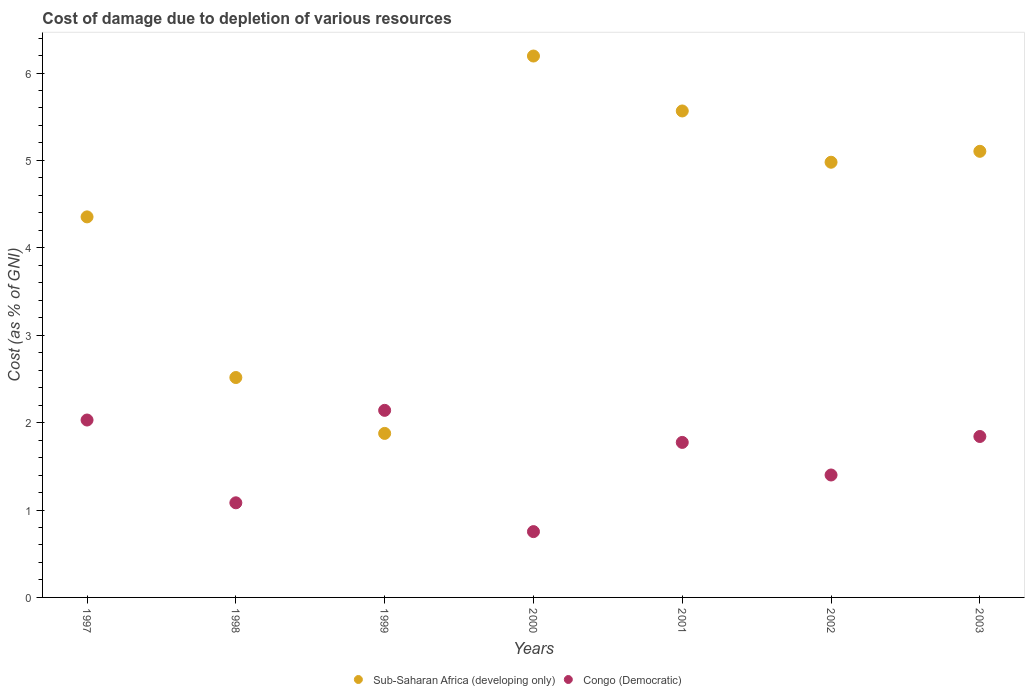How many different coloured dotlines are there?
Offer a very short reply. 2. Is the number of dotlines equal to the number of legend labels?
Ensure brevity in your answer.  Yes. What is the cost of damage caused due to the depletion of various resources in Sub-Saharan Africa (developing only) in 1998?
Make the answer very short. 2.52. Across all years, what is the maximum cost of damage caused due to the depletion of various resources in Congo (Democratic)?
Your answer should be compact. 2.14. Across all years, what is the minimum cost of damage caused due to the depletion of various resources in Congo (Democratic)?
Your answer should be compact. 0.75. In which year was the cost of damage caused due to the depletion of various resources in Sub-Saharan Africa (developing only) minimum?
Provide a succinct answer. 1999. What is the total cost of damage caused due to the depletion of various resources in Sub-Saharan Africa (developing only) in the graph?
Ensure brevity in your answer.  30.59. What is the difference between the cost of damage caused due to the depletion of various resources in Sub-Saharan Africa (developing only) in 1998 and that in 1999?
Your answer should be compact. 0.64. What is the difference between the cost of damage caused due to the depletion of various resources in Sub-Saharan Africa (developing only) in 2002 and the cost of damage caused due to the depletion of various resources in Congo (Democratic) in 2003?
Ensure brevity in your answer.  3.14. What is the average cost of damage caused due to the depletion of various resources in Congo (Democratic) per year?
Your response must be concise. 1.57. In the year 2001, what is the difference between the cost of damage caused due to the depletion of various resources in Sub-Saharan Africa (developing only) and cost of damage caused due to the depletion of various resources in Congo (Democratic)?
Offer a terse response. 3.79. What is the ratio of the cost of damage caused due to the depletion of various resources in Congo (Democratic) in 1999 to that in 2002?
Your response must be concise. 1.53. What is the difference between the highest and the second highest cost of damage caused due to the depletion of various resources in Sub-Saharan Africa (developing only)?
Ensure brevity in your answer.  0.63. What is the difference between the highest and the lowest cost of damage caused due to the depletion of various resources in Sub-Saharan Africa (developing only)?
Your answer should be compact. 4.32. Does the cost of damage caused due to the depletion of various resources in Congo (Democratic) monotonically increase over the years?
Keep it short and to the point. No. Is the cost of damage caused due to the depletion of various resources in Congo (Democratic) strictly greater than the cost of damage caused due to the depletion of various resources in Sub-Saharan Africa (developing only) over the years?
Your answer should be compact. No. How many dotlines are there?
Provide a short and direct response. 2. Are the values on the major ticks of Y-axis written in scientific E-notation?
Offer a very short reply. No. Does the graph contain any zero values?
Your answer should be compact. No. Does the graph contain grids?
Ensure brevity in your answer.  No. Where does the legend appear in the graph?
Offer a very short reply. Bottom center. How are the legend labels stacked?
Provide a succinct answer. Horizontal. What is the title of the graph?
Provide a short and direct response. Cost of damage due to depletion of various resources. Does "Antigua and Barbuda" appear as one of the legend labels in the graph?
Provide a short and direct response. No. What is the label or title of the X-axis?
Provide a short and direct response. Years. What is the label or title of the Y-axis?
Make the answer very short. Cost (as % of GNI). What is the Cost (as % of GNI) in Sub-Saharan Africa (developing only) in 1997?
Make the answer very short. 4.35. What is the Cost (as % of GNI) of Congo (Democratic) in 1997?
Make the answer very short. 2.03. What is the Cost (as % of GNI) in Sub-Saharan Africa (developing only) in 1998?
Ensure brevity in your answer.  2.52. What is the Cost (as % of GNI) of Congo (Democratic) in 1998?
Ensure brevity in your answer.  1.08. What is the Cost (as % of GNI) of Sub-Saharan Africa (developing only) in 1999?
Your answer should be compact. 1.88. What is the Cost (as % of GNI) of Congo (Democratic) in 1999?
Offer a terse response. 2.14. What is the Cost (as % of GNI) of Sub-Saharan Africa (developing only) in 2000?
Offer a terse response. 6.19. What is the Cost (as % of GNI) in Congo (Democratic) in 2000?
Offer a very short reply. 0.75. What is the Cost (as % of GNI) in Sub-Saharan Africa (developing only) in 2001?
Your answer should be very brief. 5.57. What is the Cost (as % of GNI) of Congo (Democratic) in 2001?
Make the answer very short. 1.77. What is the Cost (as % of GNI) in Sub-Saharan Africa (developing only) in 2002?
Give a very brief answer. 4.98. What is the Cost (as % of GNI) in Congo (Democratic) in 2002?
Make the answer very short. 1.4. What is the Cost (as % of GNI) of Sub-Saharan Africa (developing only) in 2003?
Make the answer very short. 5.1. What is the Cost (as % of GNI) of Congo (Democratic) in 2003?
Give a very brief answer. 1.84. Across all years, what is the maximum Cost (as % of GNI) of Sub-Saharan Africa (developing only)?
Your response must be concise. 6.19. Across all years, what is the maximum Cost (as % of GNI) in Congo (Democratic)?
Offer a terse response. 2.14. Across all years, what is the minimum Cost (as % of GNI) of Sub-Saharan Africa (developing only)?
Make the answer very short. 1.88. Across all years, what is the minimum Cost (as % of GNI) in Congo (Democratic)?
Your response must be concise. 0.75. What is the total Cost (as % of GNI) of Sub-Saharan Africa (developing only) in the graph?
Give a very brief answer. 30.59. What is the total Cost (as % of GNI) in Congo (Democratic) in the graph?
Provide a succinct answer. 11.02. What is the difference between the Cost (as % of GNI) in Sub-Saharan Africa (developing only) in 1997 and that in 1998?
Provide a short and direct response. 1.84. What is the difference between the Cost (as % of GNI) of Congo (Democratic) in 1997 and that in 1998?
Your answer should be compact. 0.95. What is the difference between the Cost (as % of GNI) in Sub-Saharan Africa (developing only) in 1997 and that in 1999?
Provide a short and direct response. 2.48. What is the difference between the Cost (as % of GNI) in Congo (Democratic) in 1997 and that in 1999?
Offer a very short reply. -0.11. What is the difference between the Cost (as % of GNI) in Sub-Saharan Africa (developing only) in 1997 and that in 2000?
Offer a very short reply. -1.84. What is the difference between the Cost (as % of GNI) in Congo (Democratic) in 1997 and that in 2000?
Your response must be concise. 1.28. What is the difference between the Cost (as % of GNI) in Sub-Saharan Africa (developing only) in 1997 and that in 2001?
Give a very brief answer. -1.21. What is the difference between the Cost (as % of GNI) in Congo (Democratic) in 1997 and that in 2001?
Offer a very short reply. 0.26. What is the difference between the Cost (as % of GNI) in Sub-Saharan Africa (developing only) in 1997 and that in 2002?
Your response must be concise. -0.63. What is the difference between the Cost (as % of GNI) of Congo (Democratic) in 1997 and that in 2002?
Your response must be concise. 0.63. What is the difference between the Cost (as % of GNI) in Sub-Saharan Africa (developing only) in 1997 and that in 2003?
Provide a succinct answer. -0.75. What is the difference between the Cost (as % of GNI) of Congo (Democratic) in 1997 and that in 2003?
Your answer should be very brief. 0.19. What is the difference between the Cost (as % of GNI) of Sub-Saharan Africa (developing only) in 1998 and that in 1999?
Make the answer very short. 0.64. What is the difference between the Cost (as % of GNI) of Congo (Democratic) in 1998 and that in 1999?
Your response must be concise. -1.06. What is the difference between the Cost (as % of GNI) in Sub-Saharan Africa (developing only) in 1998 and that in 2000?
Your answer should be very brief. -3.68. What is the difference between the Cost (as % of GNI) of Congo (Democratic) in 1998 and that in 2000?
Your response must be concise. 0.33. What is the difference between the Cost (as % of GNI) of Sub-Saharan Africa (developing only) in 1998 and that in 2001?
Keep it short and to the point. -3.05. What is the difference between the Cost (as % of GNI) in Congo (Democratic) in 1998 and that in 2001?
Make the answer very short. -0.69. What is the difference between the Cost (as % of GNI) in Sub-Saharan Africa (developing only) in 1998 and that in 2002?
Offer a terse response. -2.46. What is the difference between the Cost (as % of GNI) of Congo (Democratic) in 1998 and that in 2002?
Your answer should be compact. -0.32. What is the difference between the Cost (as % of GNI) of Sub-Saharan Africa (developing only) in 1998 and that in 2003?
Offer a very short reply. -2.59. What is the difference between the Cost (as % of GNI) in Congo (Democratic) in 1998 and that in 2003?
Offer a very short reply. -0.76. What is the difference between the Cost (as % of GNI) of Sub-Saharan Africa (developing only) in 1999 and that in 2000?
Your response must be concise. -4.32. What is the difference between the Cost (as % of GNI) in Congo (Democratic) in 1999 and that in 2000?
Provide a short and direct response. 1.39. What is the difference between the Cost (as % of GNI) of Sub-Saharan Africa (developing only) in 1999 and that in 2001?
Your response must be concise. -3.69. What is the difference between the Cost (as % of GNI) in Congo (Democratic) in 1999 and that in 2001?
Give a very brief answer. 0.37. What is the difference between the Cost (as % of GNI) in Sub-Saharan Africa (developing only) in 1999 and that in 2002?
Your answer should be very brief. -3.1. What is the difference between the Cost (as % of GNI) of Congo (Democratic) in 1999 and that in 2002?
Your answer should be very brief. 0.74. What is the difference between the Cost (as % of GNI) of Sub-Saharan Africa (developing only) in 1999 and that in 2003?
Offer a terse response. -3.23. What is the difference between the Cost (as % of GNI) in Congo (Democratic) in 1999 and that in 2003?
Your response must be concise. 0.3. What is the difference between the Cost (as % of GNI) in Sub-Saharan Africa (developing only) in 2000 and that in 2001?
Your answer should be compact. 0.63. What is the difference between the Cost (as % of GNI) of Congo (Democratic) in 2000 and that in 2001?
Provide a succinct answer. -1.02. What is the difference between the Cost (as % of GNI) of Sub-Saharan Africa (developing only) in 2000 and that in 2002?
Provide a short and direct response. 1.22. What is the difference between the Cost (as % of GNI) in Congo (Democratic) in 2000 and that in 2002?
Offer a very short reply. -0.65. What is the difference between the Cost (as % of GNI) of Sub-Saharan Africa (developing only) in 2000 and that in 2003?
Ensure brevity in your answer.  1.09. What is the difference between the Cost (as % of GNI) of Congo (Democratic) in 2000 and that in 2003?
Your answer should be compact. -1.09. What is the difference between the Cost (as % of GNI) in Sub-Saharan Africa (developing only) in 2001 and that in 2002?
Your answer should be compact. 0.59. What is the difference between the Cost (as % of GNI) in Congo (Democratic) in 2001 and that in 2002?
Your answer should be compact. 0.37. What is the difference between the Cost (as % of GNI) in Sub-Saharan Africa (developing only) in 2001 and that in 2003?
Give a very brief answer. 0.46. What is the difference between the Cost (as % of GNI) in Congo (Democratic) in 2001 and that in 2003?
Provide a succinct answer. -0.07. What is the difference between the Cost (as % of GNI) of Sub-Saharan Africa (developing only) in 2002 and that in 2003?
Offer a very short reply. -0.12. What is the difference between the Cost (as % of GNI) of Congo (Democratic) in 2002 and that in 2003?
Your response must be concise. -0.44. What is the difference between the Cost (as % of GNI) in Sub-Saharan Africa (developing only) in 1997 and the Cost (as % of GNI) in Congo (Democratic) in 1998?
Keep it short and to the point. 3.27. What is the difference between the Cost (as % of GNI) of Sub-Saharan Africa (developing only) in 1997 and the Cost (as % of GNI) of Congo (Democratic) in 1999?
Provide a succinct answer. 2.21. What is the difference between the Cost (as % of GNI) of Sub-Saharan Africa (developing only) in 1997 and the Cost (as % of GNI) of Congo (Democratic) in 2000?
Offer a very short reply. 3.6. What is the difference between the Cost (as % of GNI) of Sub-Saharan Africa (developing only) in 1997 and the Cost (as % of GNI) of Congo (Democratic) in 2001?
Provide a succinct answer. 2.58. What is the difference between the Cost (as % of GNI) of Sub-Saharan Africa (developing only) in 1997 and the Cost (as % of GNI) of Congo (Democratic) in 2002?
Provide a succinct answer. 2.95. What is the difference between the Cost (as % of GNI) of Sub-Saharan Africa (developing only) in 1997 and the Cost (as % of GNI) of Congo (Democratic) in 2003?
Your answer should be compact. 2.51. What is the difference between the Cost (as % of GNI) of Sub-Saharan Africa (developing only) in 1998 and the Cost (as % of GNI) of Congo (Democratic) in 1999?
Provide a succinct answer. 0.38. What is the difference between the Cost (as % of GNI) in Sub-Saharan Africa (developing only) in 1998 and the Cost (as % of GNI) in Congo (Democratic) in 2000?
Give a very brief answer. 1.76. What is the difference between the Cost (as % of GNI) in Sub-Saharan Africa (developing only) in 1998 and the Cost (as % of GNI) in Congo (Democratic) in 2001?
Your answer should be compact. 0.74. What is the difference between the Cost (as % of GNI) of Sub-Saharan Africa (developing only) in 1998 and the Cost (as % of GNI) of Congo (Democratic) in 2002?
Give a very brief answer. 1.12. What is the difference between the Cost (as % of GNI) of Sub-Saharan Africa (developing only) in 1998 and the Cost (as % of GNI) of Congo (Democratic) in 2003?
Provide a succinct answer. 0.67. What is the difference between the Cost (as % of GNI) of Sub-Saharan Africa (developing only) in 1999 and the Cost (as % of GNI) of Congo (Democratic) in 2000?
Your answer should be compact. 1.12. What is the difference between the Cost (as % of GNI) of Sub-Saharan Africa (developing only) in 1999 and the Cost (as % of GNI) of Congo (Democratic) in 2001?
Make the answer very short. 0.1. What is the difference between the Cost (as % of GNI) in Sub-Saharan Africa (developing only) in 1999 and the Cost (as % of GNI) in Congo (Democratic) in 2002?
Your response must be concise. 0.48. What is the difference between the Cost (as % of GNI) in Sub-Saharan Africa (developing only) in 1999 and the Cost (as % of GNI) in Congo (Democratic) in 2003?
Your answer should be very brief. 0.04. What is the difference between the Cost (as % of GNI) of Sub-Saharan Africa (developing only) in 2000 and the Cost (as % of GNI) of Congo (Democratic) in 2001?
Your response must be concise. 4.42. What is the difference between the Cost (as % of GNI) of Sub-Saharan Africa (developing only) in 2000 and the Cost (as % of GNI) of Congo (Democratic) in 2002?
Make the answer very short. 4.79. What is the difference between the Cost (as % of GNI) in Sub-Saharan Africa (developing only) in 2000 and the Cost (as % of GNI) in Congo (Democratic) in 2003?
Give a very brief answer. 4.35. What is the difference between the Cost (as % of GNI) of Sub-Saharan Africa (developing only) in 2001 and the Cost (as % of GNI) of Congo (Democratic) in 2002?
Keep it short and to the point. 4.16. What is the difference between the Cost (as % of GNI) in Sub-Saharan Africa (developing only) in 2001 and the Cost (as % of GNI) in Congo (Democratic) in 2003?
Give a very brief answer. 3.72. What is the difference between the Cost (as % of GNI) in Sub-Saharan Africa (developing only) in 2002 and the Cost (as % of GNI) in Congo (Democratic) in 2003?
Ensure brevity in your answer.  3.14. What is the average Cost (as % of GNI) in Sub-Saharan Africa (developing only) per year?
Ensure brevity in your answer.  4.37. What is the average Cost (as % of GNI) of Congo (Democratic) per year?
Make the answer very short. 1.57. In the year 1997, what is the difference between the Cost (as % of GNI) in Sub-Saharan Africa (developing only) and Cost (as % of GNI) in Congo (Democratic)?
Ensure brevity in your answer.  2.32. In the year 1998, what is the difference between the Cost (as % of GNI) in Sub-Saharan Africa (developing only) and Cost (as % of GNI) in Congo (Democratic)?
Provide a succinct answer. 1.43. In the year 1999, what is the difference between the Cost (as % of GNI) of Sub-Saharan Africa (developing only) and Cost (as % of GNI) of Congo (Democratic)?
Ensure brevity in your answer.  -0.26. In the year 2000, what is the difference between the Cost (as % of GNI) of Sub-Saharan Africa (developing only) and Cost (as % of GNI) of Congo (Democratic)?
Keep it short and to the point. 5.44. In the year 2001, what is the difference between the Cost (as % of GNI) of Sub-Saharan Africa (developing only) and Cost (as % of GNI) of Congo (Democratic)?
Your answer should be compact. 3.79. In the year 2002, what is the difference between the Cost (as % of GNI) of Sub-Saharan Africa (developing only) and Cost (as % of GNI) of Congo (Democratic)?
Keep it short and to the point. 3.58. In the year 2003, what is the difference between the Cost (as % of GNI) of Sub-Saharan Africa (developing only) and Cost (as % of GNI) of Congo (Democratic)?
Give a very brief answer. 3.26. What is the ratio of the Cost (as % of GNI) of Sub-Saharan Africa (developing only) in 1997 to that in 1998?
Give a very brief answer. 1.73. What is the ratio of the Cost (as % of GNI) in Congo (Democratic) in 1997 to that in 1998?
Provide a short and direct response. 1.88. What is the ratio of the Cost (as % of GNI) of Sub-Saharan Africa (developing only) in 1997 to that in 1999?
Provide a succinct answer. 2.32. What is the ratio of the Cost (as % of GNI) of Congo (Democratic) in 1997 to that in 1999?
Your answer should be very brief. 0.95. What is the ratio of the Cost (as % of GNI) in Sub-Saharan Africa (developing only) in 1997 to that in 2000?
Give a very brief answer. 0.7. What is the ratio of the Cost (as % of GNI) in Congo (Democratic) in 1997 to that in 2000?
Give a very brief answer. 2.7. What is the ratio of the Cost (as % of GNI) of Sub-Saharan Africa (developing only) in 1997 to that in 2001?
Keep it short and to the point. 0.78. What is the ratio of the Cost (as % of GNI) of Congo (Democratic) in 1997 to that in 2001?
Make the answer very short. 1.14. What is the ratio of the Cost (as % of GNI) in Sub-Saharan Africa (developing only) in 1997 to that in 2002?
Provide a succinct answer. 0.87. What is the ratio of the Cost (as % of GNI) in Congo (Democratic) in 1997 to that in 2002?
Offer a very short reply. 1.45. What is the ratio of the Cost (as % of GNI) in Sub-Saharan Africa (developing only) in 1997 to that in 2003?
Offer a terse response. 0.85. What is the ratio of the Cost (as % of GNI) in Congo (Democratic) in 1997 to that in 2003?
Give a very brief answer. 1.1. What is the ratio of the Cost (as % of GNI) in Sub-Saharan Africa (developing only) in 1998 to that in 1999?
Ensure brevity in your answer.  1.34. What is the ratio of the Cost (as % of GNI) of Congo (Democratic) in 1998 to that in 1999?
Give a very brief answer. 0.51. What is the ratio of the Cost (as % of GNI) in Sub-Saharan Africa (developing only) in 1998 to that in 2000?
Offer a very short reply. 0.41. What is the ratio of the Cost (as % of GNI) in Congo (Democratic) in 1998 to that in 2000?
Offer a terse response. 1.44. What is the ratio of the Cost (as % of GNI) in Sub-Saharan Africa (developing only) in 1998 to that in 2001?
Ensure brevity in your answer.  0.45. What is the ratio of the Cost (as % of GNI) in Congo (Democratic) in 1998 to that in 2001?
Ensure brevity in your answer.  0.61. What is the ratio of the Cost (as % of GNI) in Sub-Saharan Africa (developing only) in 1998 to that in 2002?
Provide a succinct answer. 0.51. What is the ratio of the Cost (as % of GNI) in Congo (Democratic) in 1998 to that in 2002?
Provide a short and direct response. 0.77. What is the ratio of the Cost (as % of GNI) of Sub-Saharan Africa (developing only) in 1998 to that in 2003?
Your answer should be compact. 0.49. What is the ratio of the Cost (as % of GNI) in Congo (Democratic) in 1998 to that in 2003?
Provide a short and direct response. 0.59. What is the ratio of the Cost (as % of GNI) of Sub-Saharan Africa (developing only) in 1999 to that in 2000?
Ensure brevity in your answer.  0.3. What is the ratio of the Cost (as % of GNI) of Congo (Democratic) in 1999 to that in 2000?
Provide a short and direct response. 2.84. What is the ratio of the Cost (as % of GNI) of Sub-Saharan Africa (developing only) in 1999 to that in 2001?
Provide a short and direct response. 0.34. What is the ratio of the Cost (as % of GNI) in Congo (Democratic) in 1999 to that in 2001?
Your answer should be very brief. 1.21. What is the ratio of the Cost (as % of GNI) of Sub-Saharan Africa (developing only) in 1999 to that in 2002?
Your answer should be very brief. 0.38. What is the ratio of the Cost (as % of GNI) in Congo (Democratic) in 1999 to that in 2002?
Offer a terse response. 1.53. What is the ratio of the Cost (as % of GNI) in Sub-Saharan Africa (developing only) in 1999 to that in 2003?
Ensure brevity in your answer.  0.37. What is the ratio of the Cost (as % of GNI) in Congo (Democratic) in 1999 to that in 2003?
Provide a short and direct response. 1.16. What is the ratio of the Cost (as % of GNI) of Sub-Saharan Africa (developing only) in 2000 to that in 2001?
Keep it short and to the point. 1.11. What is the ratio of the Cost (as % of GNI) in Congo (Democratic) in 2000 to that in 2001?
Your response must be concise. 0.42. What is the ratio of the Cost (as % of GNI) in Sub-Saharan Africa (developing only) in 2000 to that in 2002?
Make the answer very short. 1.24. What is the ratio of the Cost (as % of GNI) of Congo (Democratic) in 2000 to that in 2002?
Keep it short and to the point. 0.54. What is the ratio of the Cost (as % of GNI) in Sub-Saharan Africa (developing only) in 2000 to that in 2003?
Offer a very short reply. 1.21. What is the ratio of the Cost (as % of GNI) of Congo (Democratic) in 2000 to that in 2003?
Your answer should be compact. 0.41. What is the ratio of the Cost (as % of GNI) in Sub-Saharan Africa (developing only) in 2001 to that in 2002?
Your answer should be very brief. 1.12. What is the ratio of the Cost (as % of GNI) in Congo (Democratic) in 2001 to that in 2002?
Provide a succinct answer. 1.27. What is the ratio of the Cost (as % of GNI) of Sub-Saharan Africa (developing only) in 2001 to that in 2003?
Your response must be concise. 1.09. What is the ratio of the Cost (as % of GNI) in Congo (Democratic) in 2001 to that in 2003?
Keep it short and to the point. 0.96. What is the ratio of the Cost (as % of GNI) in Sub-Saharan Africa (developing only) in 2002 to that in 2003?
Your answer should be compact. 0.98. What is the ratio of the Cost (as % of GNI) in Congo (Democratic) in 2002 to that in 2003?
Offer a very short reply. 0.76. What is the difference between the highest and the second highest Cost (as % of GNI) in Sub-Saharan Africa (developing only)?
Your answer should be very brief. 0.63. What is the difference between the highest and the second highest Cost (as % of GNI) of Congo (Democratic)?
Give a very brief answer. 0.11. What is the difference between the highest and the lowest Cost (as % of GNI) of Sub-Saharan Africa (developing only)?
Ensure brevity in your answer.  4.32. What is the difference between the highest and the lowest Cost (as % of GNI) of Congo (Democratic)?
Your answer should be compact. 1.39. 